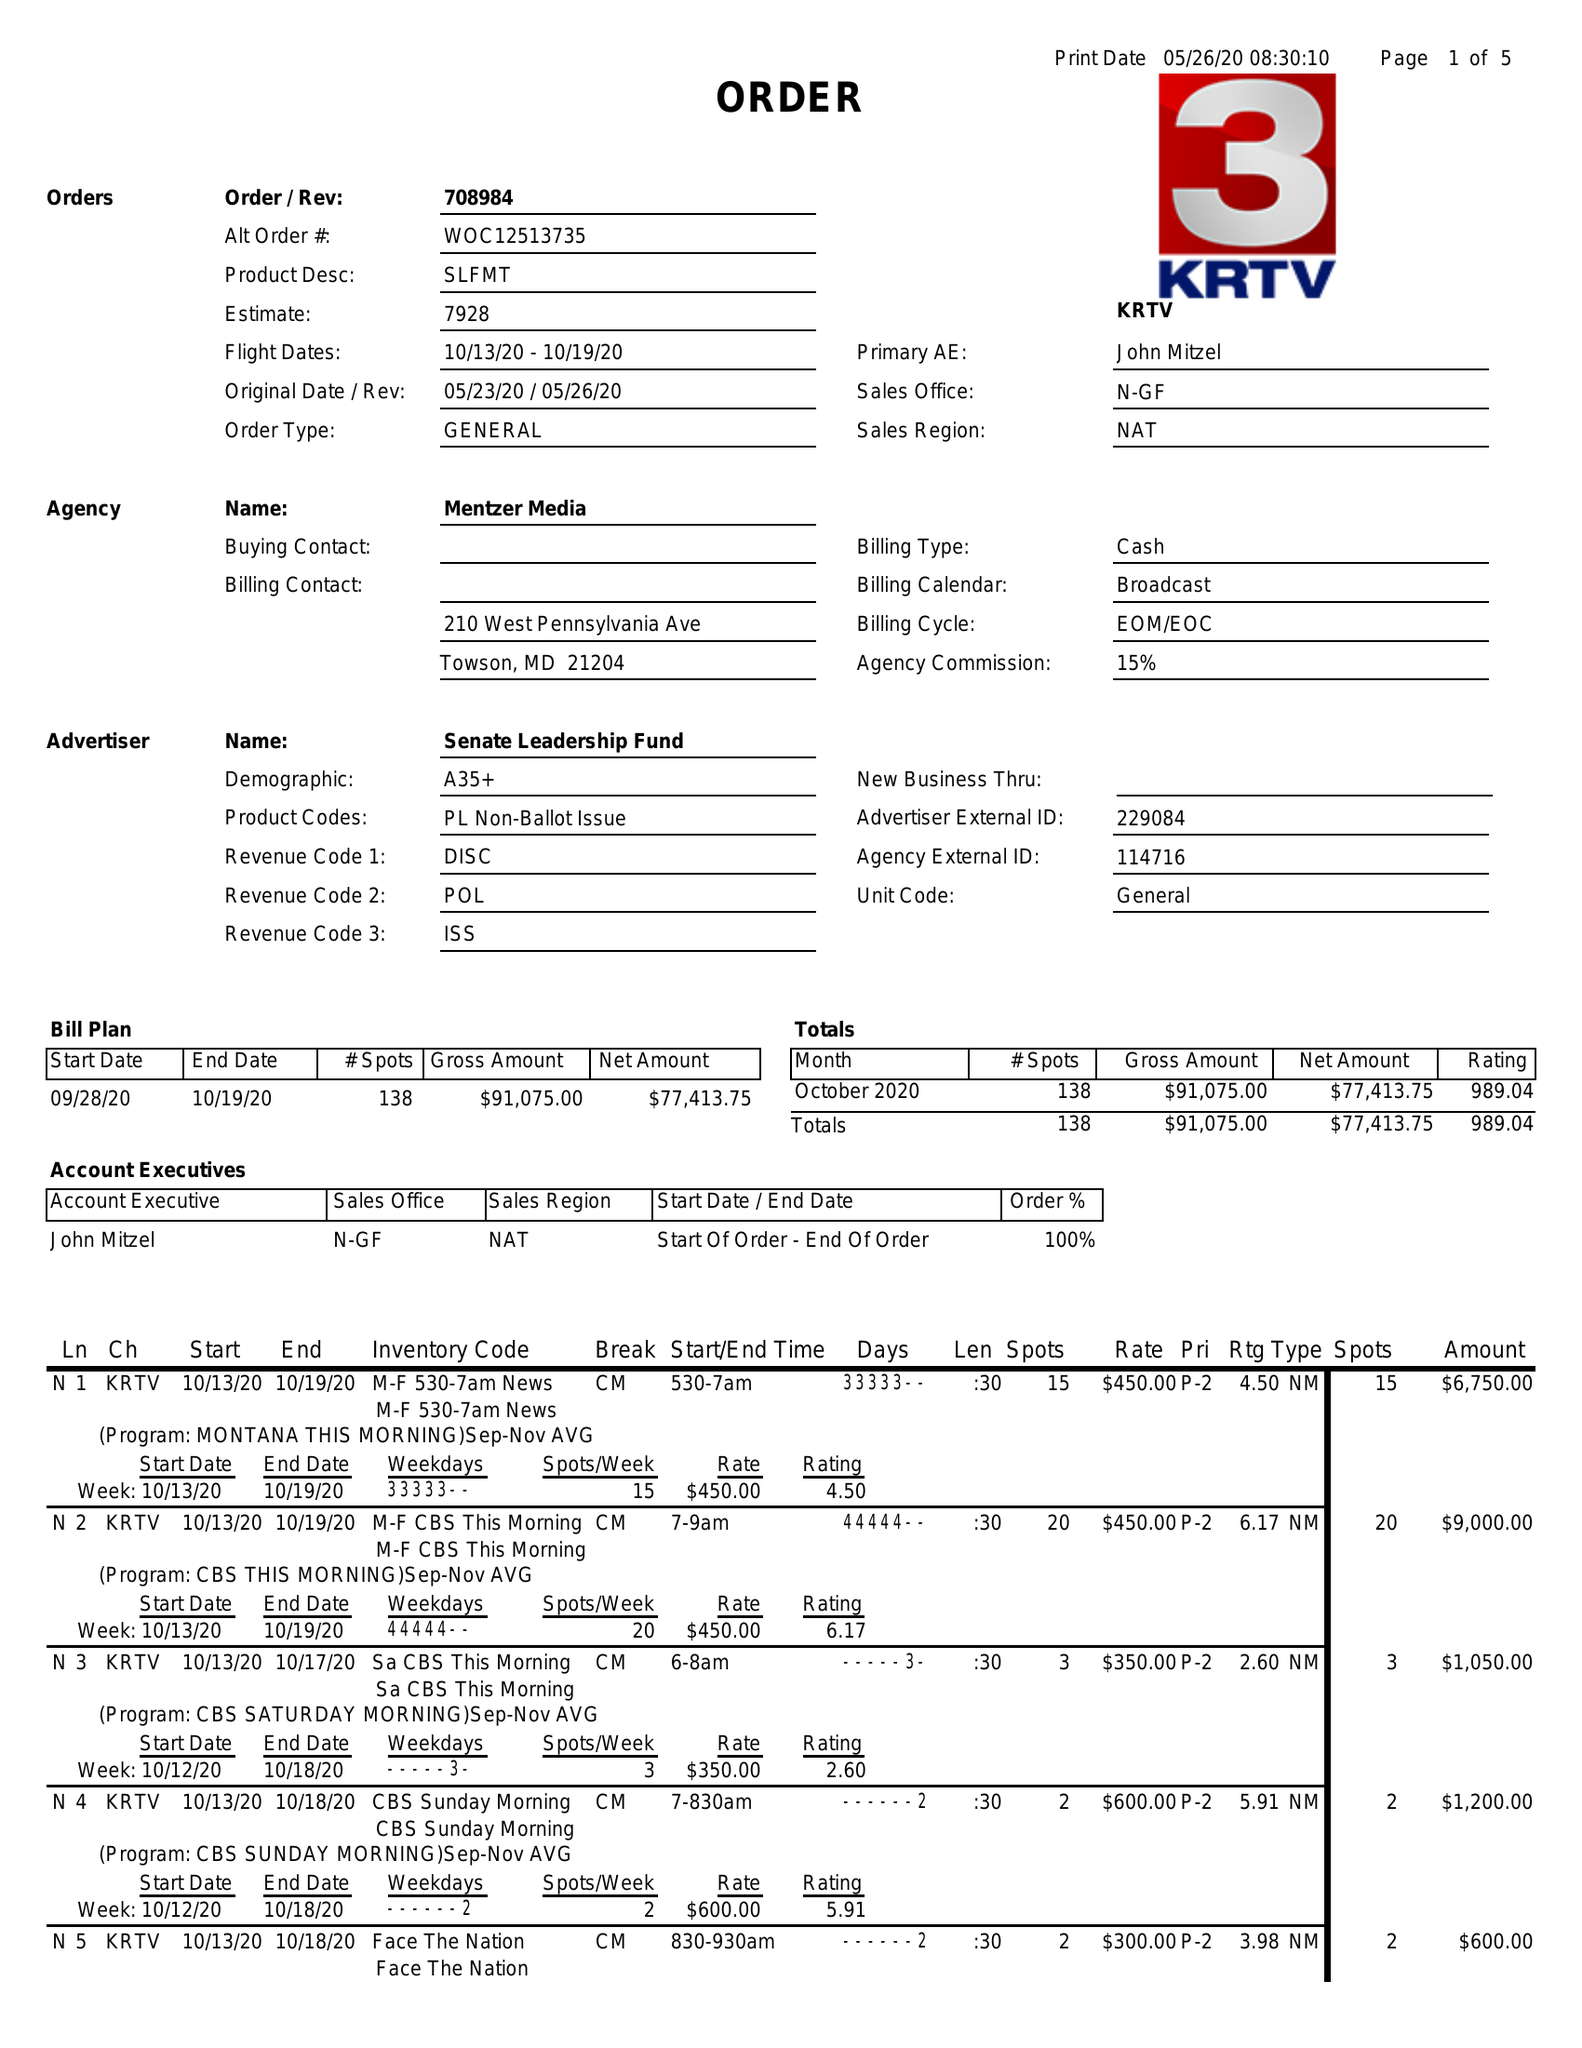What is the value for the flight_from?
Answer the question using a single word or phrase. 10/13/20 